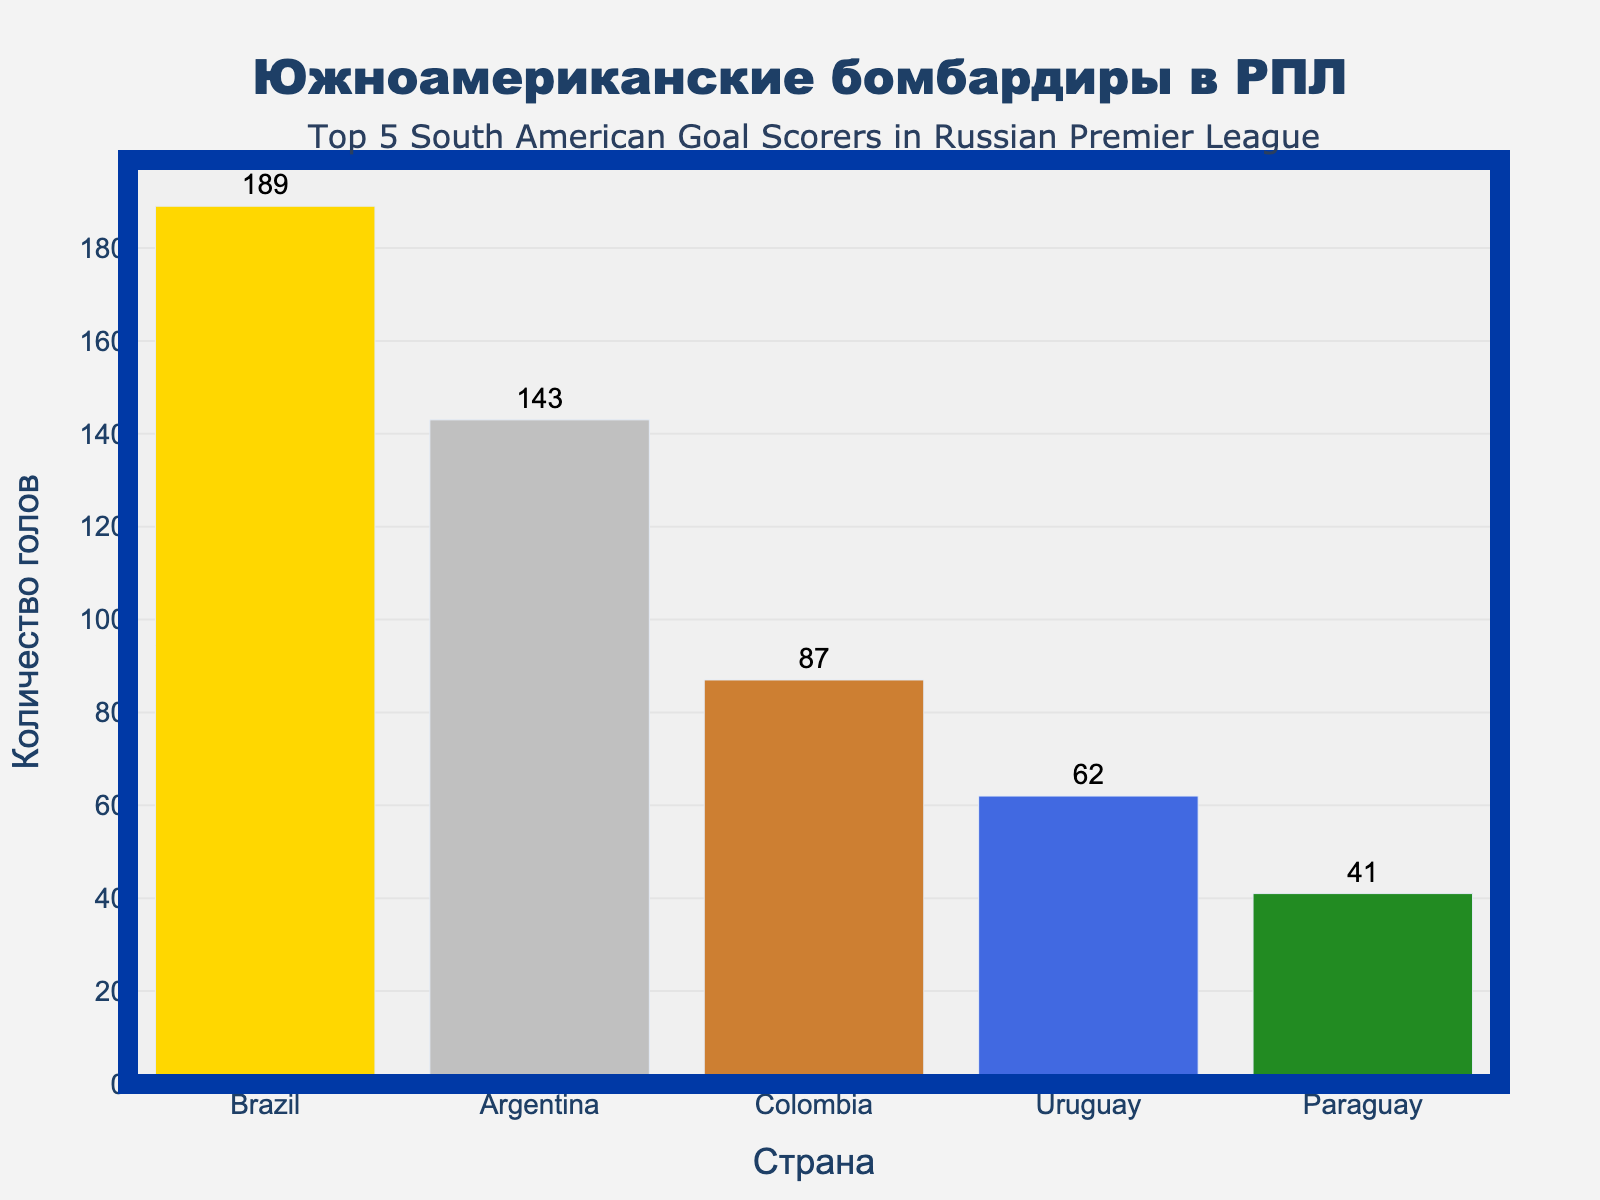Which country has scored the highest number of goals in the Russian Premier League? Brazil has the highest bar on the chart, indicating it has scored the most goals.
Answer: Brazil Which country has scored the least number of goals among the top 5 South American countries? Paraguay has the shortest bar, representing the lowest goal count among the top 5 South American countries.
Answer: Paraguay How many more goals has Brazil scored compared to Colombia? Brazil has 189 goals, and Colombia has 87 goals. Subtract the number of goals scored by Colombia from the number scored by Brazil (189 - 87).
Answer: 102 What is the total number of goals scored by all five countries combined? Sum the goals scored by each country: Brazil (189) + Argentina (143) + Colombia (87) + Uruguay (62) + Paraguay (41) = 522.
Answer: 522 Which group has a goal count closer to 100, Uruguay or Paraguay? Comparing the goal counts of Uruguay (62) and Paraguay (41) to 100, Uruguay is closer to 100.
Answer: Uruguay Which pair of countries has the closest goal differential? Calculate the goal differences: Brazil-Argentina (189-143=46), Argentina-Colombia (143-87=56), Colombia-Uruguay (87-62=25), Uruguay-Paraguay (62-41=21). Uruguay and Paraguay have the smallest differential.
Answer: Uruguay and Paraguay Is the sum of goals scored by Brazil and Argentina greater than the sum of goals scored by Colombia, Uruguay, and Paraguay? Calculate the sums: Brazil + Argentina (189 + 143 = 332) and Colombia + Uruguay + Paraguay (87 + 62 + 41 = 190). Since 332 > 190, the sum of Brazil and Argentina's goals is greater.
Answer: Yes Which country is represented with a blue bar in the chart? Based on the color scheme provided, check the goal count for the country associated with the blue bar. This corresponds to Uruguay.
Answer: Uruguay 